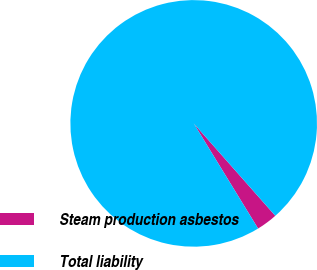Convert chart to OTSL. <chart><loc_0><loc_0><loc_500><loc_500><pie_chart><fcel>Steam production asbestos<fcel>Total liability<nl><fcel>2.77%<fcel>97.23%<nl></chart> 